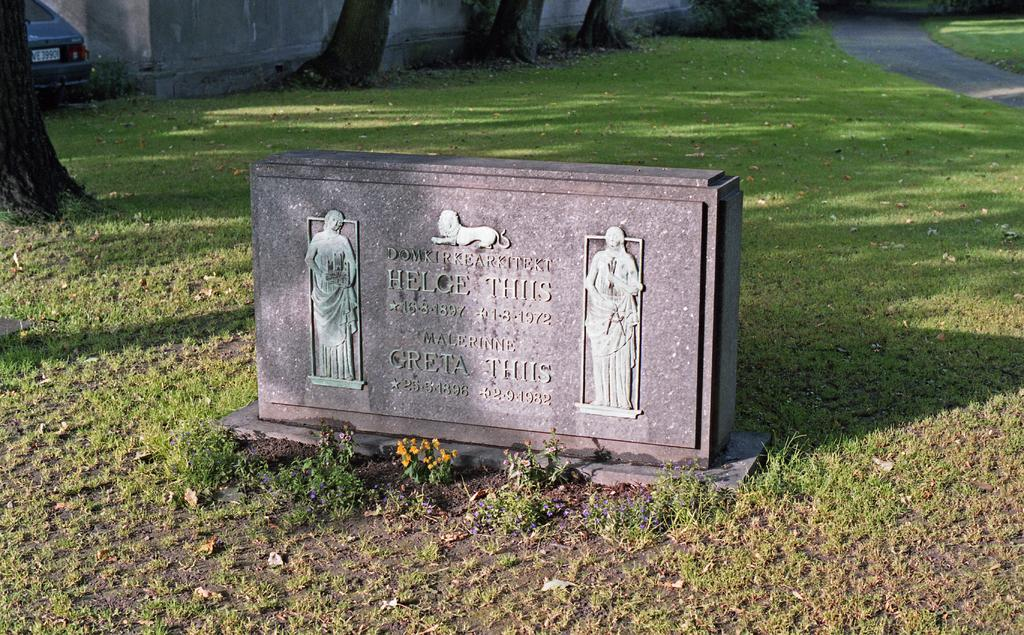What is the main subject of the image? The main subject of the image is a memorial stone. What can be seen on the memorial stone? The memorial stone has images and text on it. What type of vegetation is visible in the image? There is grass visible in the image. What type of man-made structure is present in the image? There is a road in the image. What type of natural feature is present in the image? There are trees in the image. What type of vehicle is parked in the image? There is a car parked in the image. What can be seen in the background of the image? There is a wall in the background of the image. Where are the tomatoes growing in the image? There are no tomatoes present in the image. What type of cap is the person wearing in the image? There is no person or cap present in the image. 